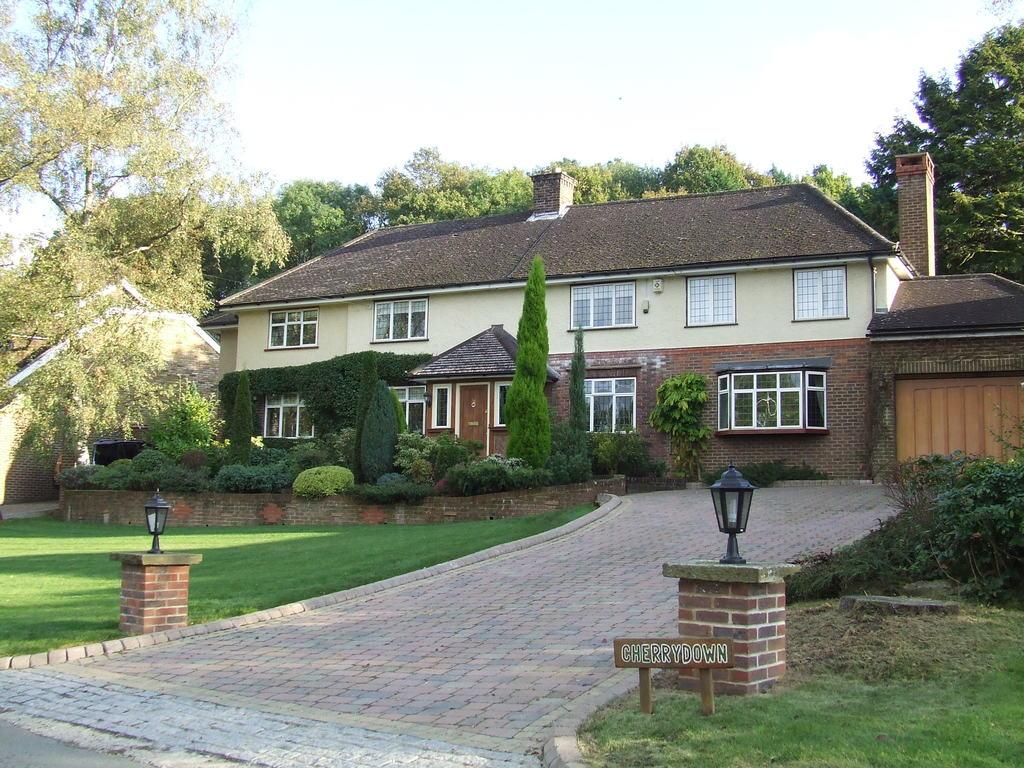What type of structures can be seen in the image? There are houses in the image. What type of vegetation is present in the image? There are trees, plants, and grass in the image. What architectural features can be seen in the image? There are windows, doors, pillars, and lamps in the image. What is the path used for in the image? The path is likely used for walking or traveling between the houses and other structures. What is the board used for in the image? The purpose of the board in the image is not clear, but it could be used for displaying information or as a surface for writing or drawing. What can be seen in the background of the image? The sky is visible in the background of the image. What type of linen is being used to teach the children in the image? There are no children or teaching activities present in the image. How many hours of sleep can be seen in the image? There is no indication of sleep or sleeping individuals in the image. 